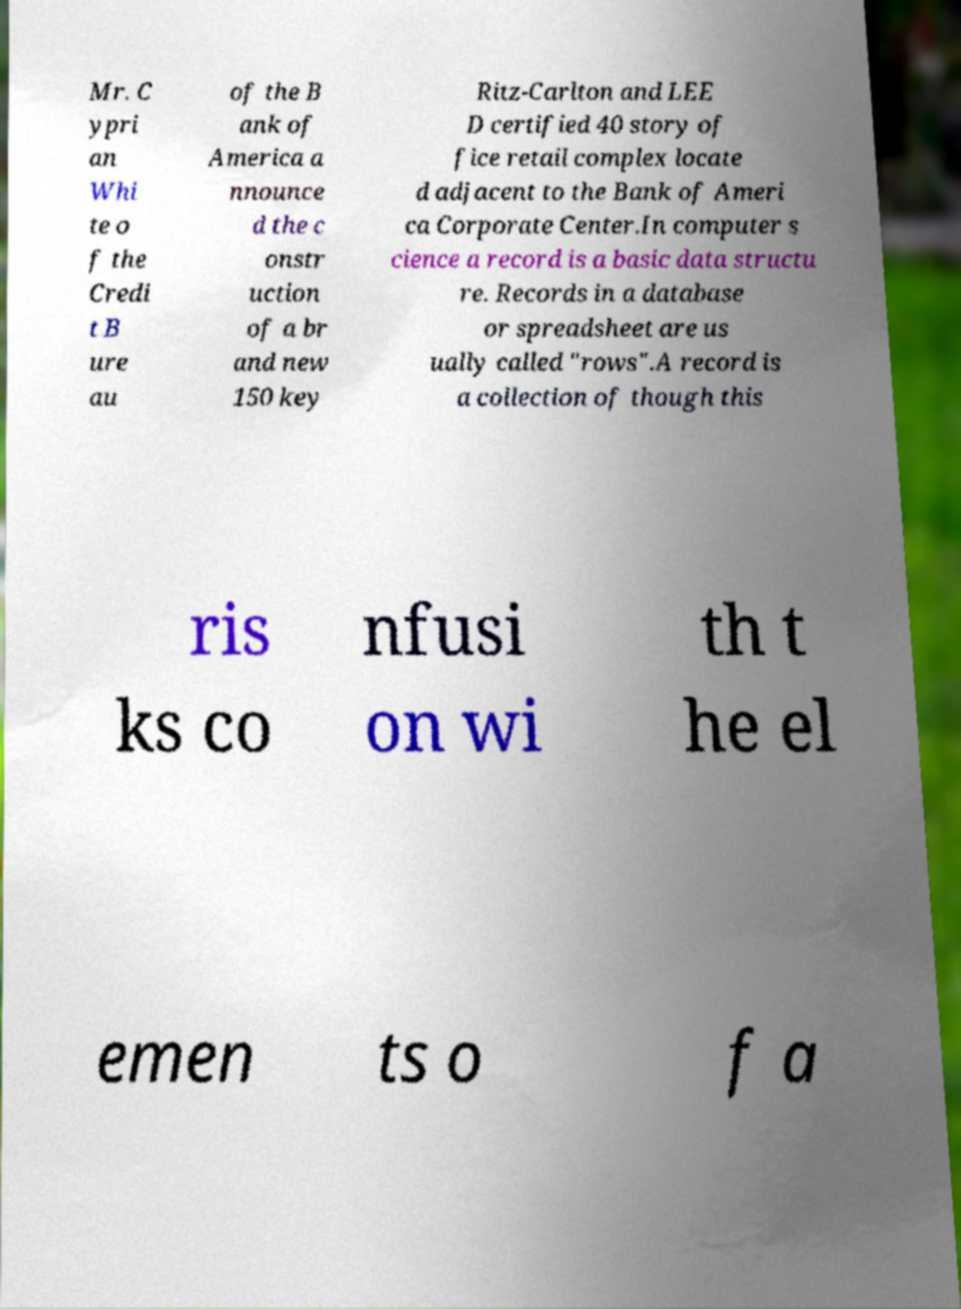Please read and relay the text visible in this image. What does it say? Mr. C ypri an Whi te o f the Credi t B ure au of the B ank of America a nnounce d the c onstr uction of a br and new 150 key Ritz-Carlton and LEE D certified 40 story of fice retail complex locate d adjacent to the Bank of Ameri ca Corporate Center.In computer s cience a record is a basic data structu re. Records in a database or spreadsheet are us ually called "rows".A record is a collection of though this ris ks co nfusi on wi th t he el emen ts o f a 